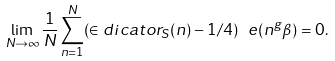Convert formula to latex. <formula><loc_0><loc_0><loc_500><loc_500>\lim _ { N \to \infty } \frac { 1 } { N } \sum _ { n = 1 } ^ { N } ( \in d i c a t o r _ { S } ( n ) - 1 / 4 ) \ \, e ( n ^ { g } \beta ) = 0 .</formula> 